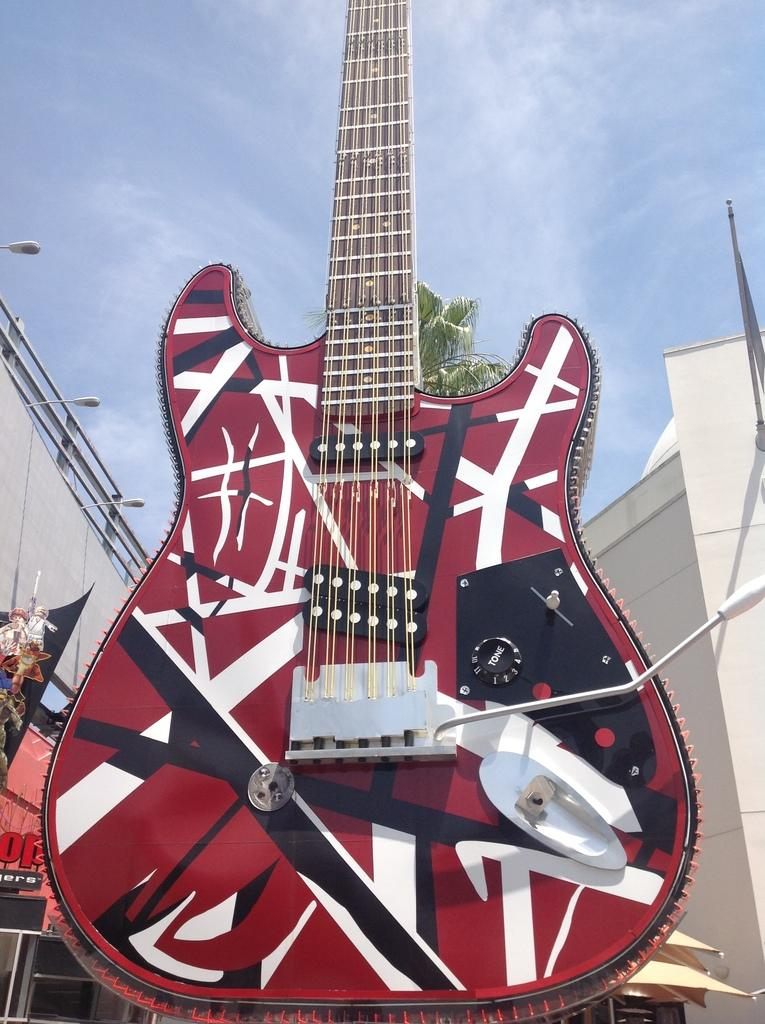What musical instrument is present in the image? There is a guitar in the picture. What is the condition of the sky in the image? The sky is cloudy in the image. What type of popcorn is being used to play the guitar in the image? There is no popcorn present in the image, and the guitar is not being played with any unconventional objects. 